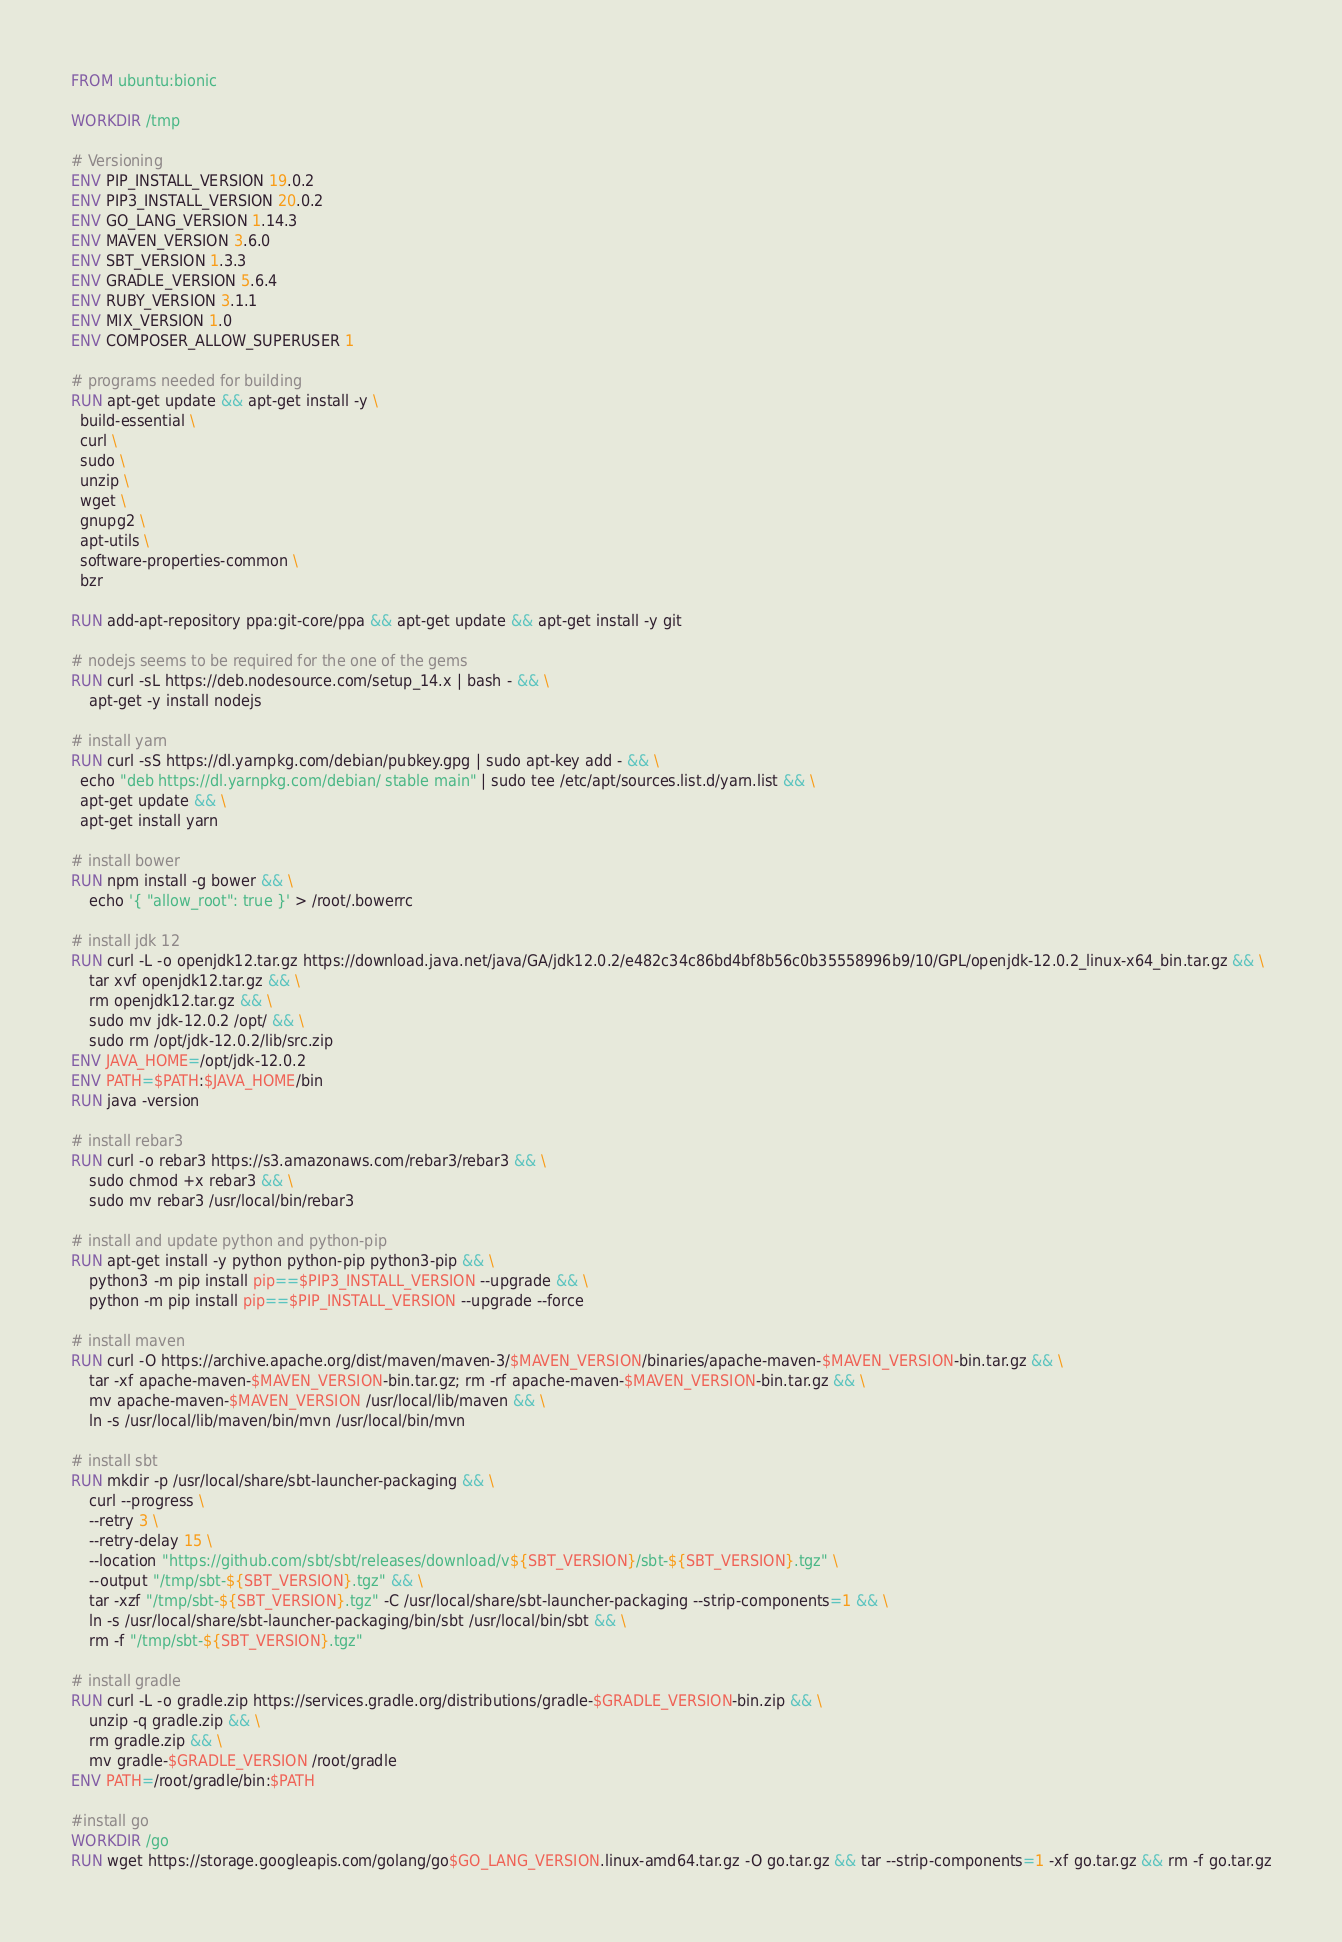<code> <loc_0><loc_0><loc_500><loc_500><_Dockerfile_>FROM ubuntu:bionic

WORKDIR /tmp

# Versioning
ENV PIP_INSTALL_VERSION 19.0.2
ENV PIP3_INSTALL_VERSION 20.0.2
ENV GO_LANG_VERSION 1.14.3
ENV MAVEN_VERSION 3.6.0
ENV SBT_VERSION 1.3.3
ENV GRADLE_VERSION 5.6.4
ENV RUBY_VERSION 3.1.1
ENV MIX_VERSION 1.0
ENV COMPOSER_ALLOW_SUPERUSER 1

# programs needed for building
RUN apt-get update && apt-get install -y \
  build-essential \
  curl \
  sudo \
  unzip \
  wget \
  gnupg2 \
  apt-utils \
  software-properties-common \
  bzr

RUN add-apt-repository ppa:git-core/ppa && apt-get update && apt-get install -y git

# nodejs seems to be required for the one of the gems
RUN curl -sL https://deb.nodesource.com/setup_14.x | bash - && \
    apt-get -y install nodejs

# install yarn
RUN curl -sS https://dl.yarnpkg.com/debian/pubkey.gpg | sudo apt-key add - && \
  echo "deb https://dl.yarnpkg.com/debian/ stable main" | sudo tee /etc/apt/sources.list.d/yarn.list && \
  apt-get update && \
  apt-get install yarn

# install bower
RUN npm install -g bower && \
    echo '{ "allow_root": true }' > /root/.bowerrc

# install jdk 12
RUN curl -L -o openjdk12.tar.gz https://download.java.net/java/GA/jdk12.0.2/e482c34c86bd4bf8b56c0b35558996b9/10/GPL/openjdk-12.0.2_linux-x64_bin.tar.gz && \
    tar xvf openjdk12.tar.gz && \
    rm openjdk12.tar.gz && \
    sudo mv jdk-12.0.2 /opt/ && \
    sudo rm /opt/jdk-12.0.2/lib/src.zip
ENV JAVA_HOME=/opt/jdk-12.0.2
ENV PATH=$PATH:$JAVA_HOME/bin
RUN java -version

# install rebar3
RUN curl -o rebar3 https://s3.amazonaws.com/rebar3/rebar3 && \
    sudo chmod +x rebar3 && \
    sudo mv rebar3 /usr/local/bin/rebar3

# install and update python and python-pip
RUN apt-get install -y python python-pip python3-pip && \
    python3 -m pip install pip==$PIP3_INSTALL_VERSION --upgrade && \
    python -m pip install pip==$PIP_INSTALL_VERSION --upgrade --force

# install maven
RUN curl -O https://archive.apache.org/dist/maven/maven-3/$MAVEN_VERSION/binaries/apache-maven-$MAVEN_VERSION-bin.tar.gz && \
    tar -xf apache-maven-$MAVEN_VERSION-bin.tar.gz; rm -rf apache-maven-$MAVEN_VERSION-bin.tar.gz && \
    mv apache-maven-$MAVEN_VERSION /usr/local/lib/maven && \
    ln -s /usr/local/lib/maven/bin/mvn /usr/local/bin/mvn

# install sbt
RUN mkdir -p /usr/local/share/sbt-launcher-packaging && \
    curl --progress \
    --retry 3 \
    --retry-delay 15 \
    --location "https://github.com/sbt/sbt/releases/download/v${SBT_VERSION}/sbt-${SBT_VERSION}.tgz" \
    --output "/tmp/sbt-${SBT_VERSION}.tgz" && \
    tar -xzf "/tmp/sbt-${SBT_VERSION}.tgz" -C /usr/local/share/sbt-launcher-packaging --strip-components=1 && \
    ln -s /usr/local/share/sbt-launcher-packaging/bin/sbt /usr/local/bin/sbt && \
    rm -f "/tmp/sbt-${SBT_VERSION}.tgz"

# install gradle
RUN curl -L -o gradle.zip https://services.gradle.org/distributions/gradle-$GRADLE_VERSION-bin.zip && \
    unzip -q gradle.zip && \
    rm gradle.zip && \
    mv gradle-$GRADLE_VERSION /root/gradle
ENV PATH=/root/gradle/bin:$PATH

#install go
WORKDIR /go
RUN wget https://storage.googleapis.com/golang/go$GO_LANG_VERSION.linux-amd64.tar.gz -O go.tar.gz && tar --strip-components=1 -xf go.tar.gz && rm -f go.tar.gz</code> 